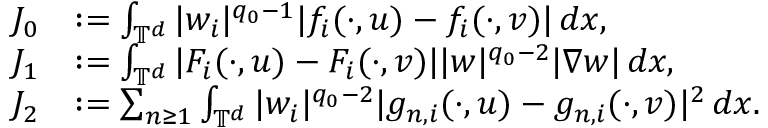Convert formula to latex. <formula><loc_0><loc_0><loc_500><loc_500>\begin{array} { r l } { J _ { 0 } } & { \colon = \int _ { \mathbb { T } ^ { d } } | w _ { i } | ^ { q _ { 0 } - 1 } | f _ { i } ( \cdot , u ) - f _ { i } ( \cdot , v ) | \, d x , } \\ { J _ { 1 } } & { \colon = \int _ { \mathbb { T } ^ { d } } | F _ { i } ( \cdot , u ) - F _ { i } ( \cdot , v ) | | w | ^ { q _ { 0 } - 2 } | \nabla w | \, d x , } \\ { J _ { 2 } } & { \colon = \sum _ { n \geq 1 } \int _ { \mathbb { T } ^ { d } } | w _ { i } | ^ { q _ { 0 } - 2 } | g _ { n , i } ( \cdot , u ) - g _ { n , i } ( \cdot , v ) | ^ { 2 } \, d x . } \end{array}</formula> 